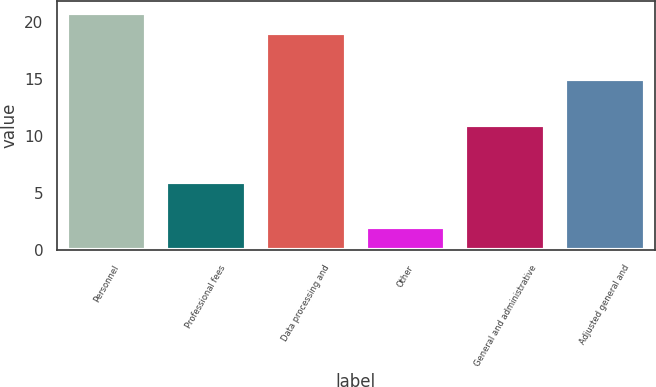<chart> <loc_0><loc_0><loc_500><loc_500><bar_chart><fcel>Personnel<fcel>Professional fees<fcel>Data processing and<fcel>Other<fcel>General and administrative<fcel>Adjusted general and<nl><fcel>20.8<fcel>6<fcel>19<fcel>2<fcel>11<fcel>15<nl></chart> 